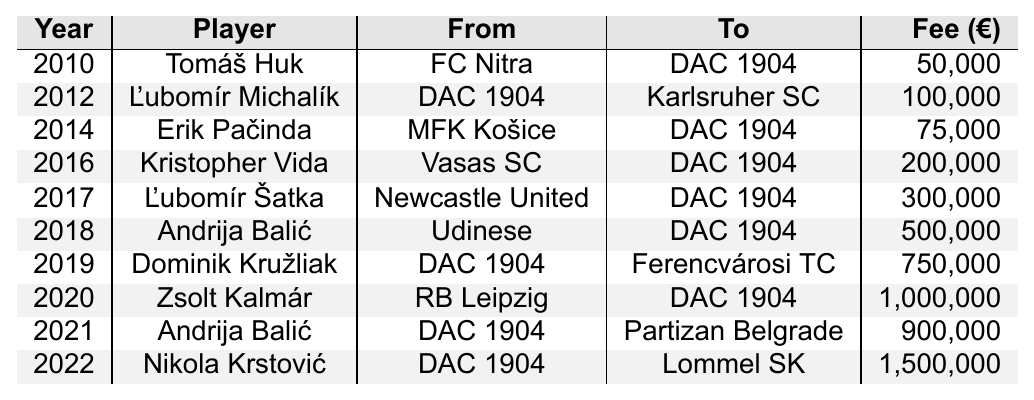What was the transfer fee for Tomáš Huk? The table shows that Tomáš Huk was transferred to DAC 1904 from FC Nitra in 2010 for a fee of 50,000 euros.
Answer: 50,000 In which year did DAC 1904 receive the highest transfer fee? The table indicates the highest transfer fee received by DAC 1904 was for Dominik Kružliak in 2019 at 750,000 euros.
Answer: 2019 How many players were transferred to DAC 1904 from other clubs between 2010 and 2022? By inspecting the table, I count the players transferred to DAC 1904 from 2010 to 2022: Tomáš Huk, Erik Pačinda, Kristopher Vida, Ľubomír Šatka, Andrija Balić, and Zsolt Kalmár; that totals 6 players.
Answer: 6 What is the total amount in fees paid by DAC 1904 for player acquisitions? The table lists DAC 1904's acquisitions fees as 50,000 + 75,000 + 200,000 + 300,000 + 500,000 + 1,000,000 = 2,125,000 euros.
Answer: 2,125,000 Did DAC 1904 make a profit by transferring Andrija Balić in 2021? According to the table, DAC 1904 sold Andrija Balić for 900,000 euros after acquiring him for 500,000 euros in 2018, indicating a profit of 400,000 euros.
Answer: Yes Which player brought in the highest transfer fee to DAC 1904 when they sold him? The highest fee noted in the table for a player leaving DAC 1904 was for Nikola Krstović in 2022, who was transferred to Lommel SK for 1,500,000 euros.
Answer: Nikola Krstović What is the average transfer fee for players coming to DAC 1904 from other clubs? Adding the fees for players acquired: 50,000 + 75,000 + 200,000 + 300,000 + 500,000 + 1,000,000 = 2,125,000 euros; dividing by 6 (the total number of acquisitions) gives an average of 354,167 euros.
Answer: 354,167 How many players did DAC 1904 transfer out between 2010 and 2022? Observing the table, I find that two players, Ľubomír Michalík and Dominik Kružliak, were transferred out of DAC 1904 during that time.
Answer: 2 What was the total transfer fee in euros for players who joined DAC 1904 from 2014 to 2022? The fees for players joining from 2014 to 2022 are: Erik Pačinda (75,000) + Kristopher Vida (200,000) + Ľubomír Šatka (300,000) + Andrija Balić (500,000) + Zsolt Kalmár (1,000,000) + Nikola Krstović (1,500,000) = 3,575,000 euros total.
Answer: 3,575,000 Did DAC 1904 spend more than 1 million euros on a single player acquisition? Checking the table, yes, DAC 1904 spent 1,000,000 euros for Zsolt Kalmár in 2020, which is indeed more than 1 million euros.
Answer: Yes Which two years saw DAC 1904 transfer out a player? The table shows that in 2012 and 2019, DAC 1904 transferred out Ľubomír Michalík and Dominik Kružliak respectively.
Answer: 2012 and 2019 